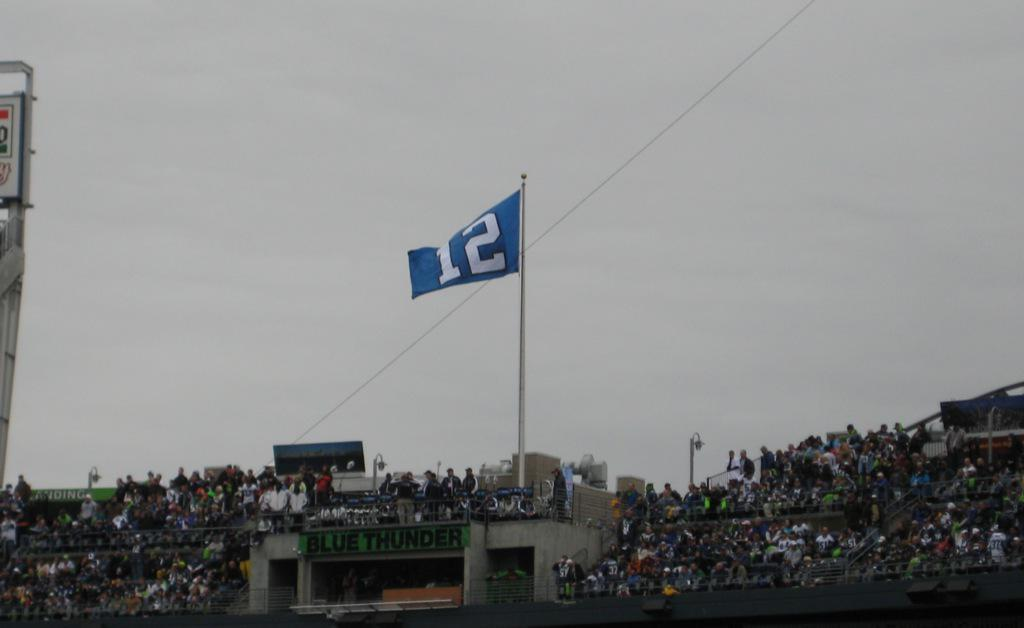What can be seen in the sky in the image? The sky is visible in the image. What is attached to the flag post in the image? There is a flag in the image. What type of lighting fixture is present in the image? A street light is present in the image. What tall structure can be seen in the image? There is a tower in the image. Who is present in the image observing the scene? Spectators are sitting in the image. What type of lumber is being used to construct the tower in the image? There is no mention of lumber or construction materials in the image; it only shows a tower. What do the spectators believe about the weather in the image? There is no information about the spectators' beliefs or the weather in the image. 